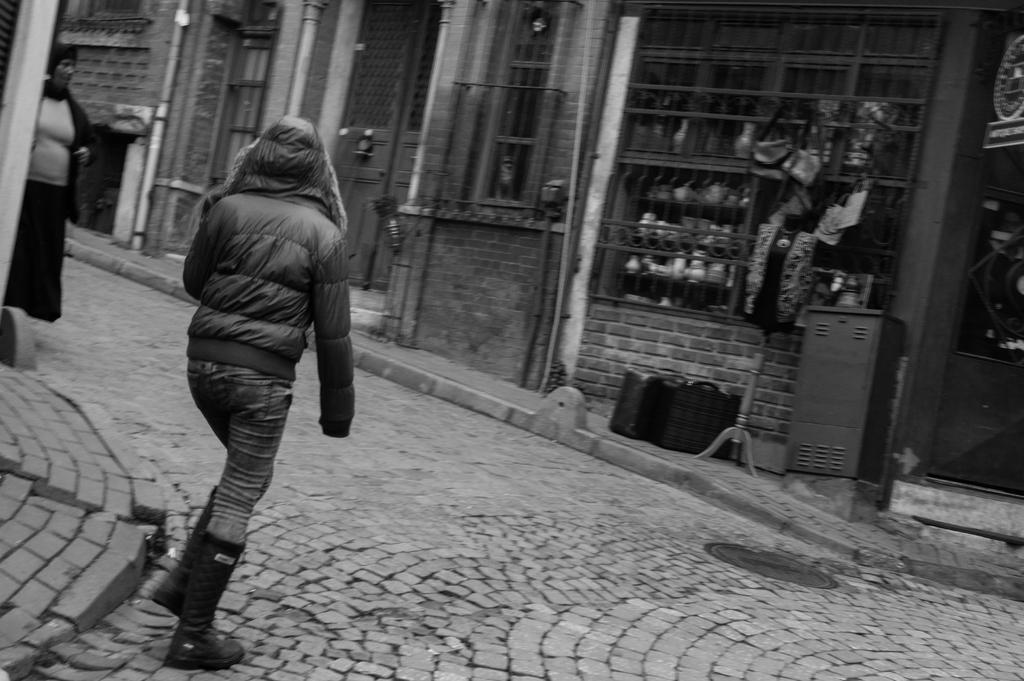In one or two sentences, can you explain what this image depicts? In this picture we can see two people on the ground and in the background we can see a building and some objects. 